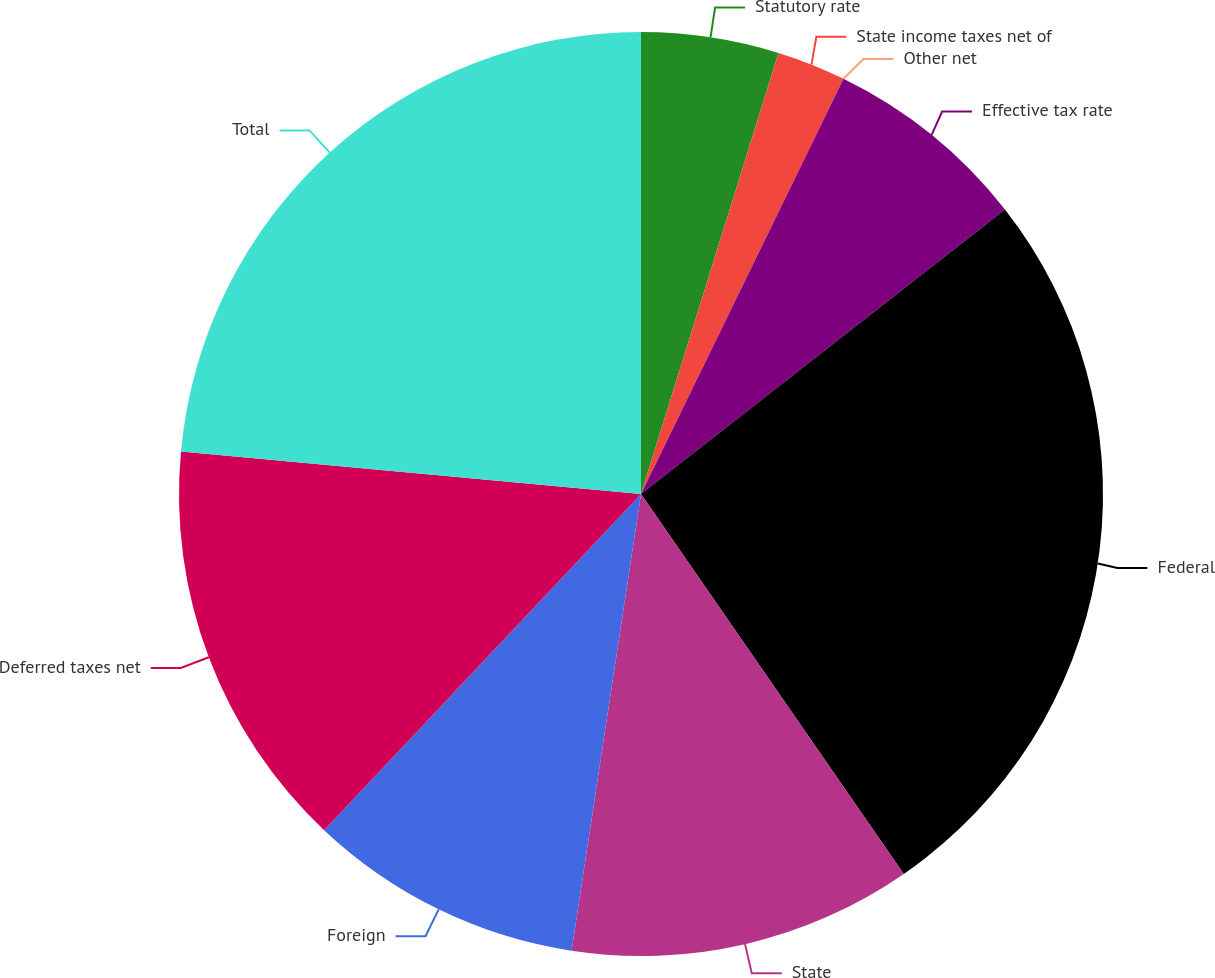Convert chart to OTSL. <chart><loc_0><loc_0><loc_500><loc_500><pie_chart><fcel>Statutory rate<fcel>State income taxes net of<fcel>Other net<fcel>Effective tax rate<fcel>Federal<fcel>State<fcel>Foreign<fcel>Deferred taxes net<fcel>Total<nl><fcel>4.81%<fcel>2.41%<fcel>0.0%<fcel>7.22%<fcel>25.93%<fcel>12.03%<fcel>9.63%<fcel>14.44%<fcel>23.53%<nl></chart> 